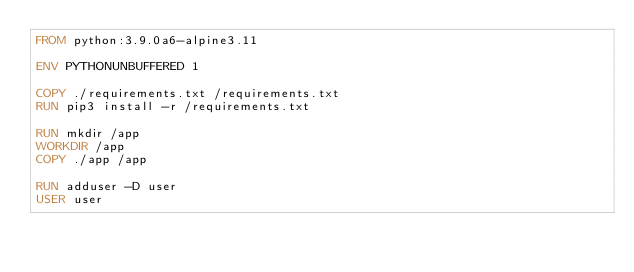Convert code to text. <code><loc_0><loc_0><loc_500><loc_500><_Dockerfile_>FROM python:3.9.0a6-alpine3.11

ENV PYTHONUNBUFFERED 1

COPY ./requirements.txt /requirements.txt
RUN pip3 install -r /requirements.txt

RUN mkdir /app
WORKDIR /app
COPY ./app /app

RUN adduser -D user
USER user
</code> 